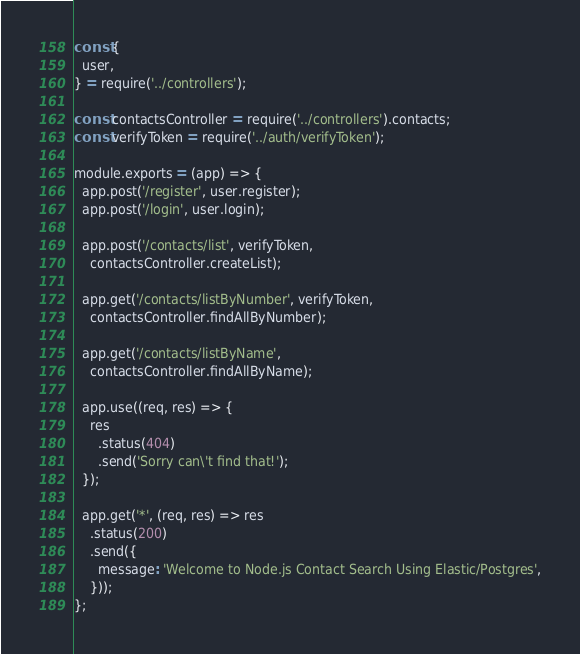Convert code to text. <code><loc_0><loc_0><loc_500><loc_500><_JavaScript_>const {
  user,
} = require('../controllers');

const contactsController = require('../controllers').contacts;
const verifyToken = require('../auth/verifyToken');

module.exports = (app) => {
  app.post('/register', user.register);
  app.post('/login', user.login);

  app.post('/contacts/list', verifyToken,
    contactsController.createList);

  app.get('/contacts/listByNumber', verifyToken,
    contactsController.findAllByNumber);

  app.get('/contacts/listByName',
    contactsController.findAllByName);

  app.use((req, res) => {
    res
      .status(404)
      .send('Sorry can\'t find that!');
  });

  app.get('*', (req, res) => res
    .status(200)
    .send({
      message: 'Welcome to Node.js Contact Search Using Elastic/Postgres',
    }));
};

</code> 